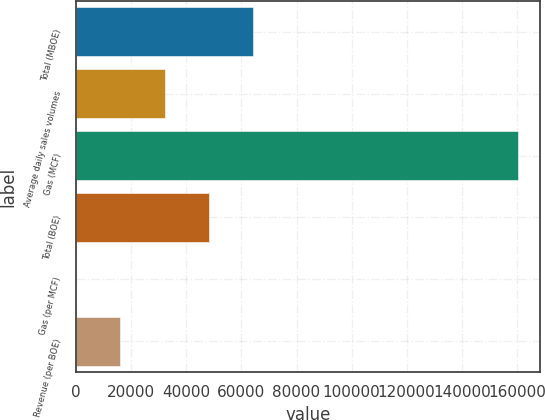Convert chart to OTSL. <chart><loc_0><loc_0><loc_500><loc_500><bar_chart><fcel>Total (MBOE)<fcel>Average daily sales volumes<fcel>Gas (MCF)<fcel>Total (BOE)<fcel>Gas (per MCF)<fcel>Revenue (per BOE)<nl><fcel>64222.3<fcel>32113<fcel>160550<fcel>48167.7<fcel>3.81<fcel>16058.4<nl></chart> 